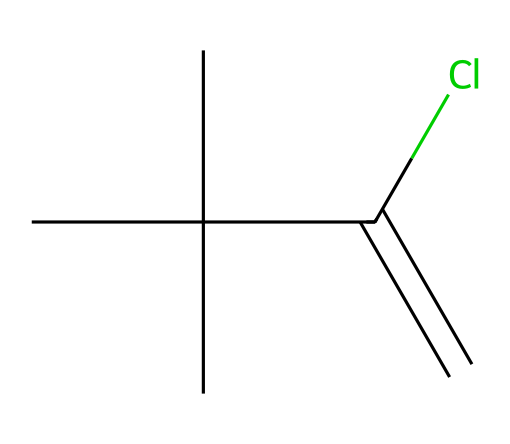What is the molecular formula of this compound? To derive the molecular formula, count the number of each type of atom present in the SMILES notation. The notation shows 5 carbon atoms (C) and 1 chlorine atom (Cl) in addition to 8 hydrogen atoms (H). Therefore, the molecular formula can be expressed as C5H8Cl.
Answer: C5H8Cl How many carbon atoms are in neoprene? By examining the SMILES structure, we can see that there are a total of 5 carbon atoms represented in the molecule. Each 'C' in the structure contributes to the total count.
Answer: 5 What type of bond connects the carbon atoms in the carbon chain? The structure depicts a carbon-carbon double bond between two of the carbon atoms, indicated by the '=' sign in the notation. This suggests the presence of unsaturation in the compound.
Answer: double bond What functional group is present in neoprene? The presence of the chlorine atom (Cl) attached to one of the carbon atoms signifies that a haloalkane functional group exists in this compound. This is characteristic of aliphatic compounds with halogen substituents.
Answer: haloalkane Does neoprene contain any functional groups that contribute to strong intermolecular forces? While neoprene is primarily comprised of hydrophobic carbon chains and has a halogen substituent, the chlorine does indeed add polar character which can lead to dipole-dipole interactions, yet it is less significant compared to compounds with -OH or -NH2 groups.
Answer: yes Is neoprene saturated or unsaturated? By looking at the presence of a double bond in the structure, we can determine that neoprene is unsaturated, meaning it contains fewer hydrogen atoms than the maximum possible for its carbon atom count.
Answer: unsaturated 